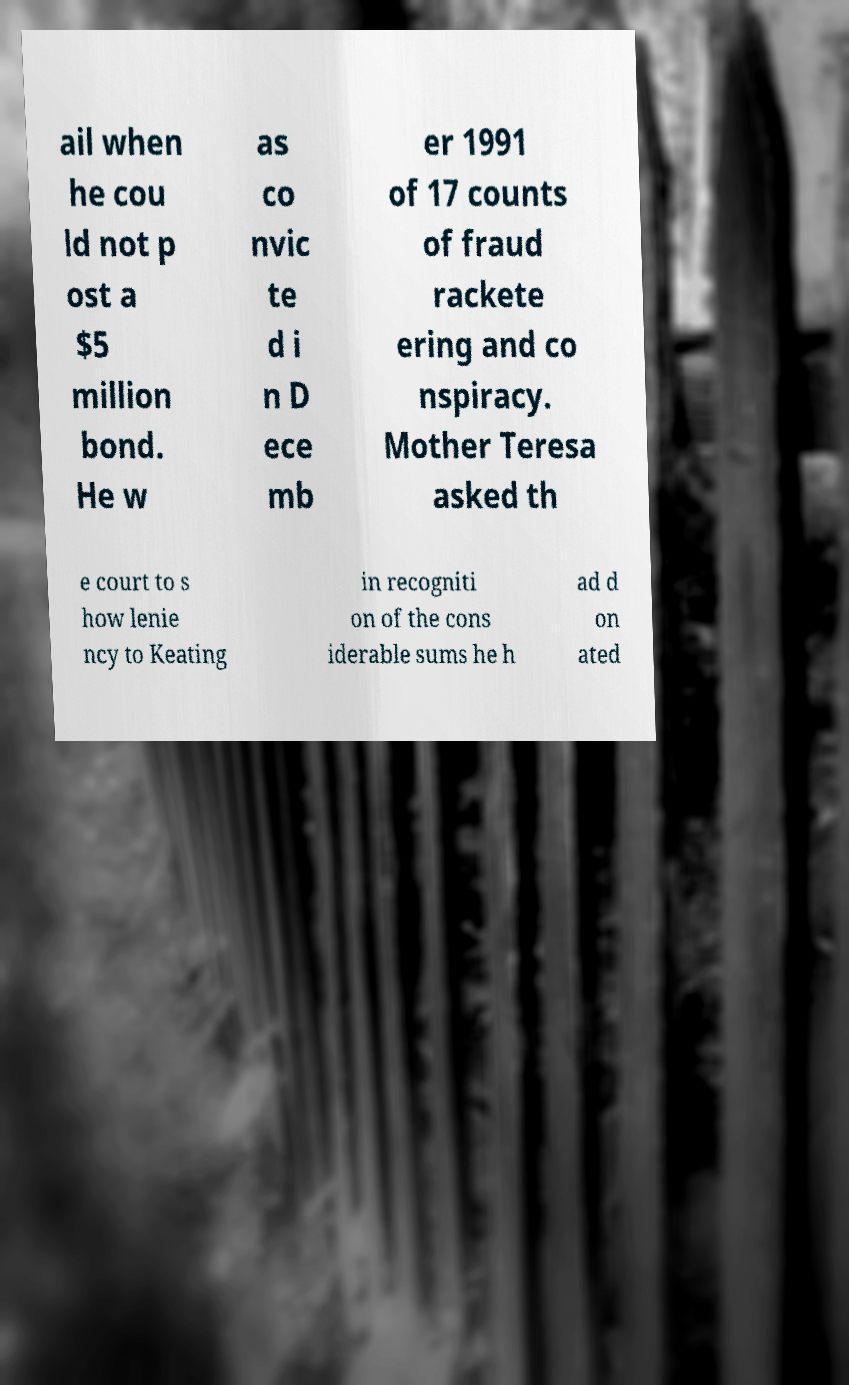Please identify and transcribe the text found in this image. ail when he cou ld not p ost a $5 million bond. He w as co nvic te d i n D ece mb er 1991 of 17 counts of fraud rackete ering and co nspiracy. Mother Teresa asked th e court to s how lenie ncy to Keating in recogniti on of the cons iderable sums he h ad d on ated 